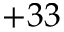Convert formula to latex. <formula><loc_0><loc_0><loc_500><loc_500>+ 3 3</formula> 